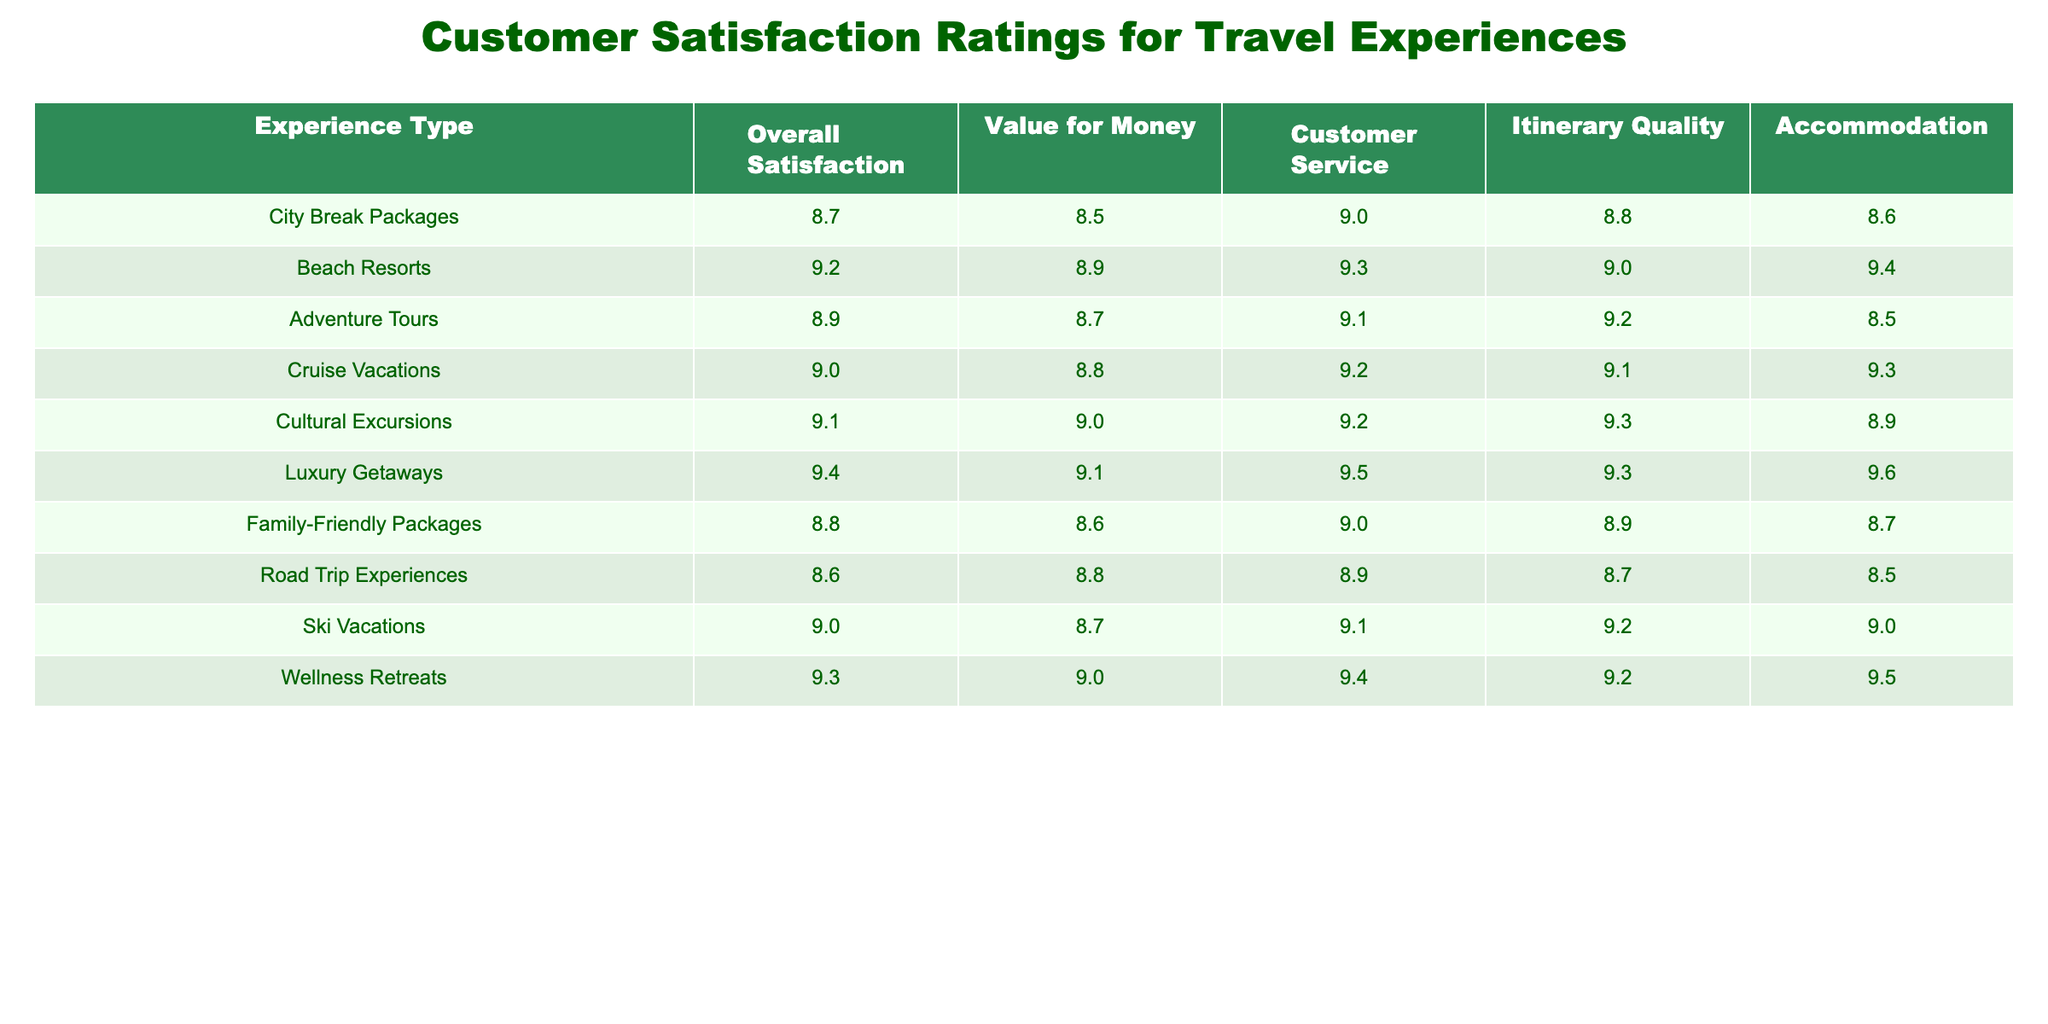What is the overall satisfaction rating for Luxury Getaways? The table shows that the overall satisfaction rating for Luxury Getaways is 9.4.
Answer: 9.4 Which experience type has the highest rating for Customer Service? By looking at the Customer Service ratings in the table, Luxury Getaways has the highest rating of 9.5.
Answer: 9.5 What is the average Value for Money rating for all experience types? To calculate the average Value for Money, we sum the values (8.5 + 8.9 + 8.7 + 8.8 + 9.0 + 9.1 + 8.6 + 8.8 + 8.7 + 9.0) = 88.6, then divide by 10 (the number of experience types), resulting in an average of 8.86.
Answer: 8.9 Is the Accommodation rating for Beach Resorts higher than that for City Break Packages? Looking at the table, Beach Resorts has an Accommodation rating of 9.4, while City Break Packages has a rating of 8.6. Since 9.4 is greater than 8.6, it is indeed higher.
Answer: Yes What is the difference in overall satisfaction between Cultural Excursions and Adventure Tours? The overall satisfaction for Cultural Excursions is 9.1, while for Adventure Tours it is 8.9. Calculating the difference: 9.1 - 8.9 = 0.2.
Answer: 0.2 